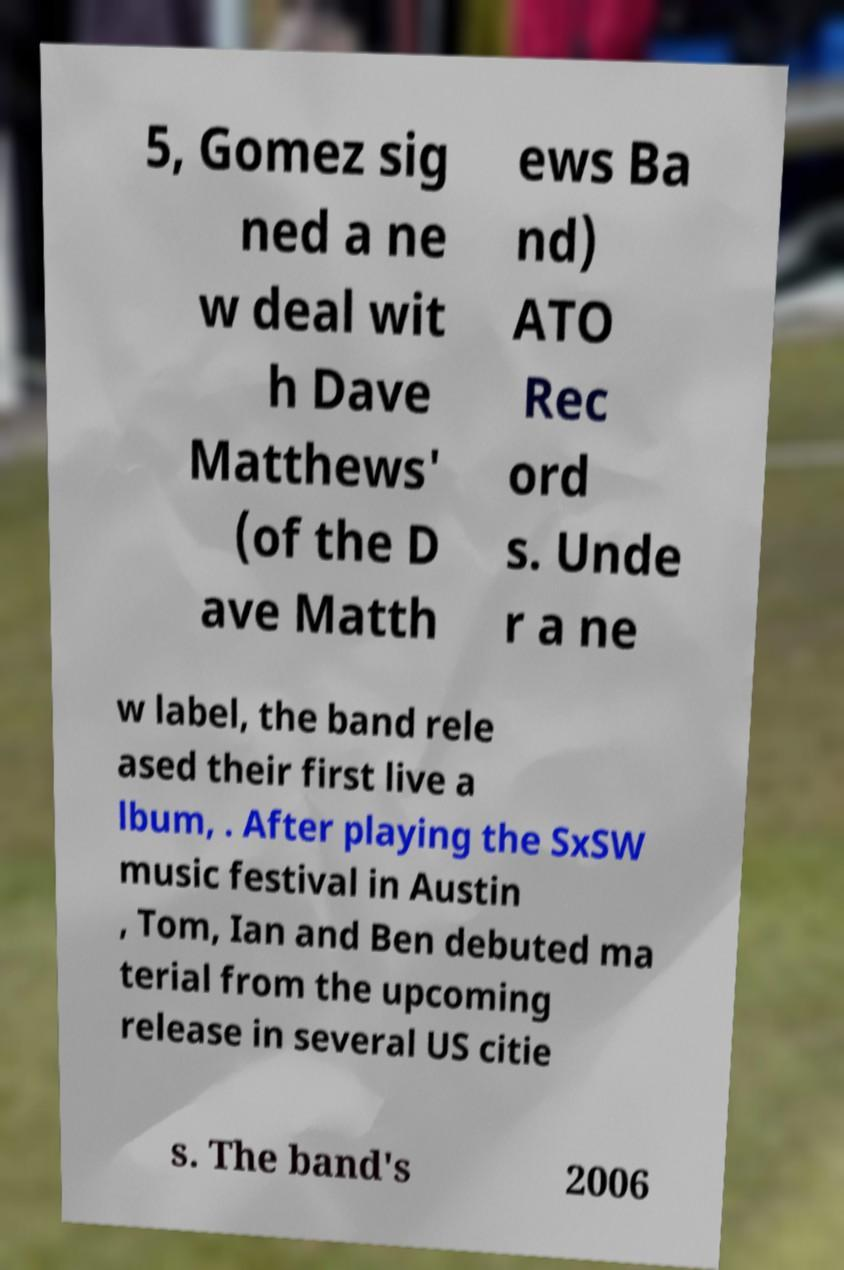Could you extract and type out the text from this image? 5, Gomez sig ned a ne w deal wit h Dave Matthews' (of the D ave Matth ews Ba nd) ATO Rec ord s. Unde r a ne w label, the band rele ased their first live a lbum, . After playing the SxSW music festival in Austin , Tom, Ian and Ben debuted ma terial from the upcoming release in several US citie s. The band's 2006 